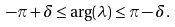<formula> <loc_0><loc_0><loc_500><loc_500>- \pi + \delta \leq \arg ( \lambda ) \leq \pi - \delta .</formula> 